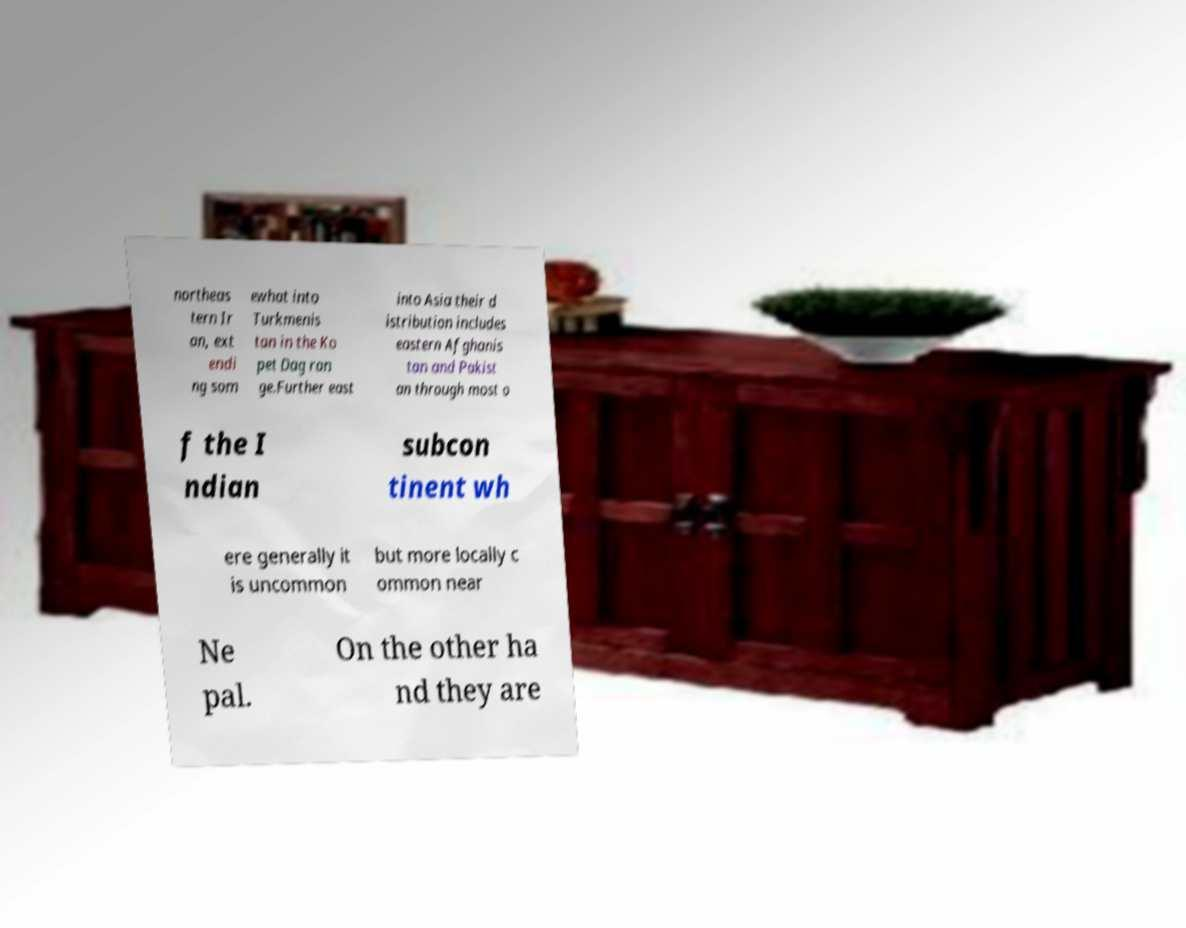What messages or text are displayed in this image? I need them in a readable, typed format. northeas tern Ir an, ext endi ng som ewhat into Turkmenis tan in the Ko pet Dag ran ge.Further east into Asia their d istribution includes eastern Afghanis tan and Pakist an through most o f the I ndian subcon tinent wh ere generally it is uncommon but more locally c ommon near Ne pal. On the other ha nd they are 